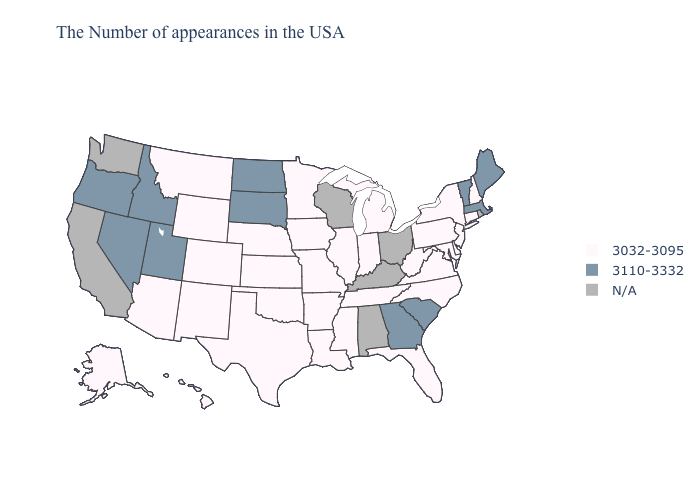Which states have the lowest value in the Northeast?
Keep it brief. New Hampshire, Connecticut, New York, New Jersey, Pennsylvania. Which states have the lowest value in the West?
Concise answer only. Wyoming, Colorado, New Mexico, Montana, Arizona, Alaska, Hawaii. Name the states that have a value in the range 3032-3095?
Answer briefly. New Hampshire, Connecticut, New York, New Jersey, Delaware, Maryland, Pennsylvania, Virginia, North Carolina, West Virginia, Florida, Michigan, Indiana, Tennessee, Illinois, Mississippi, Louisiana, Missouri, Arkansas, Minnesota, Iowa, Kansas, Nebraska, Oklahoma, Texas, Wyoming, Colorado, New Mexico, Montana, Arizona, Alaska, Hawaii. Name the states that have a value in the range 3110-3332?
Be succinct. Maine, Massachusetts, Vermont, South Carolina, Georgia, South Dakota, North Dakota, Utah, Idaho, Nevada, Oregon. What is the highest value in the USA?
Give a very brief answer. 3110-3332. Among the states that border Vermont , does New Hampshire have the lowest value?
Concise answer only. Yes. Does Georgia have the lowest value in the USA?
Short answer required. No. Name the states that have a value in the range N/A?
Quick response, please. Rhode Island, Ohio, Kentucky, Alabama, Wisconsin, California, Washington. How many symbols are there in the legend?
Be succinct. 3. Name the states that have a value in the range N/A?
Be succinct. Rhode Island, Ohio, Kentucky, Alabama, Wisconsin, California, Washington. Does South Carolina have the highest value in the South?
Give a very brief answer. Yes. 